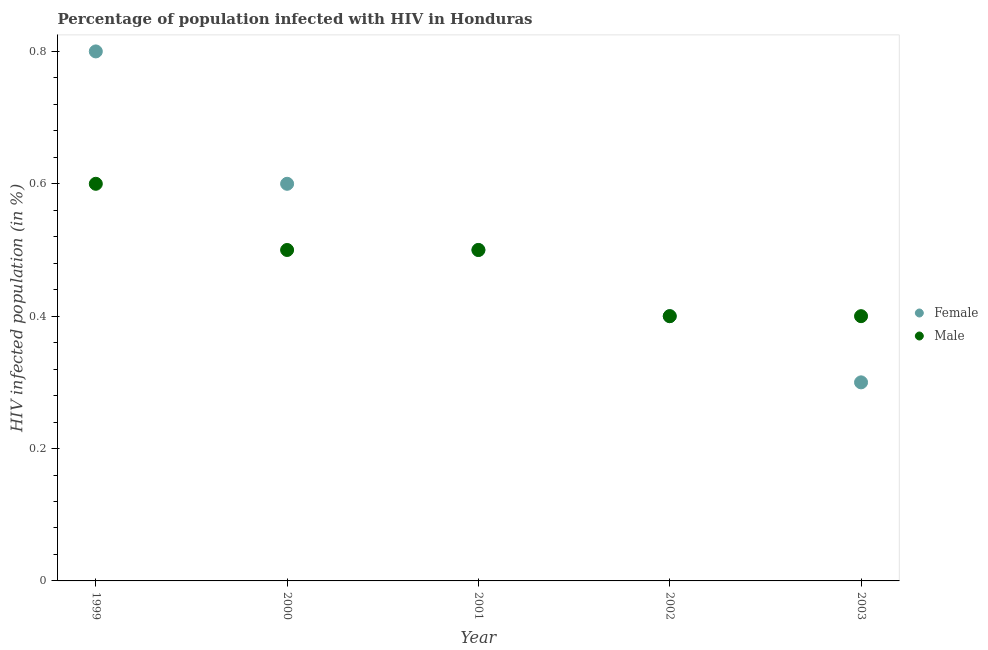What is the percentage of females who are infected with hiv in 2002?
Your answer should be very brief. 0.4. Across all years, what is the maximum percentage of males who are infected with hiv?
Provide a short and direct response. 0.6. What is the difference between the percentage of males who are infected with hiv in 1999 and that in 2001?
Ensure brevity in your answer.  0.1. What is the average percentage of females who are infected with hiv per year?
Your response must be concise. 0.52. In the year 2003, what is the difference between the percentage of females who are infected with hiv and percentage of males who are infected with hiv?
Keep it short and to the point. -0.1. What is the ratio of the percentage of males who are infected with hiv in 1999 to that in 2002?
Keep it short and to the point. 1.5. What is the difference between the highest and the second highest percentage of females who are infected with hiv?
Provide a short and direct response. 0.2. Does the percentage of males who are infected with hiv monotonically increase over the years?
Keep it short and to the point. No. What is the difference between two consecutive major ticks on the Y-axis?
Your answer should be compact. 0.2. Does the graph contain grids?
Your response must be concise. No. Where does the legend appear in the graph?
Give a very brief answer. Center right. How many legend labels are there?
Provide a succinct answer. 2. What is the title of the graph?
Give a very brief answer. Percentage of population infected with HIV in Honduras. Does "Net National savings" appear as one of the legend labels in the graph?
Keep it short and to the point. No. What is the label or title of the Y-axis?
Offer a terse response. HIV infected population (in %). What is the HIV infected population (in %) of Male in 1999?
Offer a terse response. 0.6. What is the HIV infected population (in %) of Male in 2002?
Your response must be concise. 0.4. What is the HIV infected population (in %) in Male in 2003?
Your answer should be compact. 0.4. Across all years, what is the maximum HIV infected population (in %) in Female?
Ensure brevity in your answer.  0.8. Across all years, what is the maximum HIV infected population (in %) of Male?
Offer a terse response. 0.6. What is the total HIV infected population (in %) of Male in the graph?
Provide a short and direct response. 2.4. What is the difference between the HIV infected population (in %) in Female in 1999 and that in 2000?
Ensure brevity in your answer.  0.2. What is the difference between the HIV infected population (in %) of Male in 1999 and that in 2000?
Offer a terse response. 0.1. What is the difference between the HIV infected population (in %) in Female in 1999 and that in 2001?
Provide a short and direct response. 0.3. What is the difference between the HIV infected population (in %) of Female in 1999 and that in 2003?
Your answer should be compact. 0.5. What is the difference between the HIV infected population (in %) of Male in 2000 and that in 2001?
Offer a terse response. 0. What is the difference between the HIV infected population (in %) of Female in 2000 and that in 2002?
Ensure brevity in your answer.  0.2. What is the difference between the HIV infected population (in %) of Female in 2000 and that in 2003?
Offer a very short reply. 0.3. What is the difference between the HIV infected population (in %) of Female in 2001 and that in 2002?
Your answer should be very brief. 0.1. What is the difference between the HIV infected population (in %) of Male in 2001 and that in 2002?
Offer a terse response. 0.1. What is the difference between the HIV infected population (in %) in Female in 2001 and that in 2003?
Offer a very short reply. 0.2. What is the difference between the HIV infected population (in %) of Male in 2001 and that in 2003?
Give a very brief answer. 0.1. What is the difference between the HIV infected population (in %) of Male in 2002 and that in 2003?
Give a very brief answer. 0. What is the difference between the HIV infected population (in %) of Female in 1999 and the HIV infected population (in %) of Male in 2001?
Provide a short and direct response. 0.3. What is the difference between the HIV infected population (in %) of Female in 2000 and the HIV infected population (in %) of Male in 2002?
Ensure brevity in your answer.  0.2. What is the difference between the HIV infected population (in %) in Female in 2000 and the HIV infected population (in %) in Male in 2003?
Your answer should be very brief. 0.2. What is the average HIV infected population (in %) of Female per year?
Offer a terse response. 0.52. What is the average HIV infected population (in %) of Male per year?
Your response must be concise. 0.48. In the year 1999, what is the difference between the HIV infected population (in %) of Female and HIV infected population (in %) of Male?
Provide a succinct answer. 0.2. In the year 2001, what is the difference between the HIV infected population (in %) of Female and HIV infected population (in %) of Male?
Your answer should be very brief. 0. In the year 2003, what is the difference between the HIV infected population (in %) in Female and HIV infected population (in %) in Male?
Provide a succinct answer. -0.1. What is the ratio of the HIV infected population (in %) of Male in 1999 to that in 2000?
Offer a terse response. 1.2. What is the ratio of the HIV infected population (in %) in Female in 1999 to that in 2001?
Your answer should be compact. 1.6. What is the ratio of the HIV infected population (in %) of Female in 1999 to that in 2003?
Your response must be concise. 2.67. What is the ratio of the HIV infected population (in %) in Female in 2000 to that in 2001?
Your answer should be very brief. 1.2. What is the ratio of the HIV infected population (in %) of Female in 2000 to that in 2002?
Your response must be concise. 1.5. What is the ratio of the HIV infected population (in %) in Female in 2000 to that in 2003?
Offer a terse response. 2. What is the ratio of the HIV infected population (in %) in Male in 2000 to that in 2003?
Make the answer very short. 1.25. What is the ratio of the HIV infected population (in %) of Male in 2001 to that in 2002?
Provide a short and direct response. 1.25. What is the ratio of the HIV infected population (in %) in Male in 2001 to that in 2003?
Ensure brevity in your answer.  1.25. What is the ratio of the HIV infected population (in %) of Male in 2002 to that in 2003?
Ensure brevity in your answer.  1. What is the difference between the highest and the lowest HIV infected population (in %) in Male?
Give a very brief answer. 0.2. 